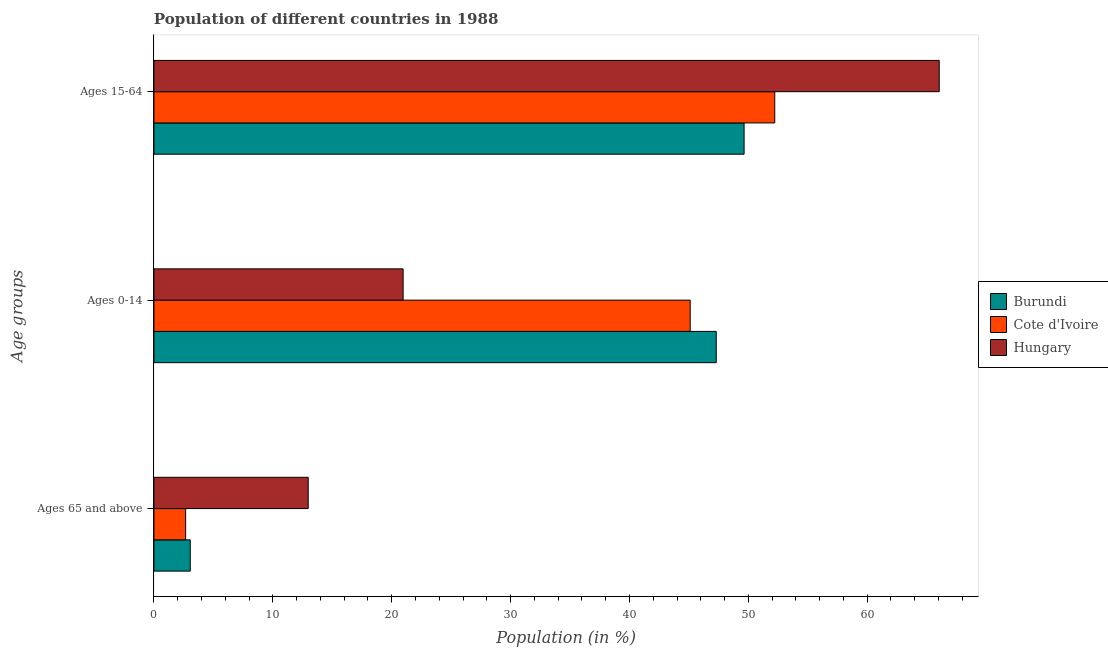How many groups of bars are there?
Your answer should be compact. 3. Are the number of bars per tick equal to the number of legend labels?
Give a very brief answer. Yes. How many bars are there on the 2nd tick from the top?
Provide a succinct answer. 3. What is the label of the 1st group of bars from the top?
Ensure brevity in your answer.  Ages 15-64. What is the percentage of population within the age-group of 65 and above in Burundi?
Ensure brevity in your answer.  3.06. Across all countries, what is the maximum percentage of population within the age-group of 65 and above?
Make the answer very short. 12.98. Across all countries, what is the minimum percentage of population within the age-group of 65 and above?
Ensure brevity in your answer.  2.67. In which country was the percentage of population within the age-group 15-64 maximum?
Offer a very short reply. Hungary. In which country was the percentage of population within the age-group 0-14 minimum?
Provide a succinct answer. Hungary. What is the total percentage of population within the age-group 15-64 in the graph?
Provide a succinct answer. 167.93. What is the difference between the percentage of population within the age-group of 65 and above in Cote d'Ivoire and that in Hungary?
Your answer should be compact. -10.31. What is the difference between the percentage of population within the age-group of 65 and above in Hungary and the percentage of population within the age-group 15-64 in Burundi?
Ensure brevity in your answer.  -36.67. What is the average percentage of population within the age-group 15-64 per country?
Offer a terse response. 55.98. What is the difference between the percentage of population within the age-group 0-14 and percentage of population within the age-group of 65 and above in Cote d'Ivoire?
Provide a short and direct response. 42.44. In how many countries, is the percentage of population within the age-group 0-14 greater than 52 %?
Your answer should be very brief. 0. What is the ratio of the percentage of population within the age-group 0-14 in Cote d'Ivoire to that in Burundi?
Your answer should be very brief. 0.95. Is the difference between the percentage of population within the age-group of 65 and above in Burundi and Hungary greater than the difference between the percentage of population within the age-group 0-14 in Burundi and Hungary?
Your response must be concise. No. What is the difference between the highest and the second highest percentage of population within the age-group 15-64?
Give a very brief answer. 13.84. What is the difference between the highest and the lowest percentage of population within the age-group 15-64?
Offer a very short reply. 16.42. Is the sum of the percentage of population within the age-group 15-64 in Hungary and Cote d'Ivoire greater than the maximum percentage of population within the age-group 0-14 across all countries?
Your answer should be compact. Yes. What does the 3rd bar from the top in Ages 15-64 represents?
Your answer should be very brief. Burundi. What does the 3rd bar from the bottom in Ages 0-14 represents?
Give a very brief answer. Hungary. What is the difference between two consecutive major ticks on the X-axis?
Keep it short and to the point. 10. Are the values on the major ticks of X-axis written in scientific E-notation?
Offer a terse response. No. How many legend labels are there?
Offer a terse response. 3. What is the title of the graph?
Make the answer very short. Population of different countries in 1988. Does "French Polynesia" appear as one of the legend labels in the graph?
Provide a short and direct response. No. What is the label or title of the X-axis?
Provide a succinct answer. Population (in %). What is the label or title of the Y-axis?
Ensure brevity in your answer.  Age groups. What is the Population (in %) in Burundi in Ages 65 and above?
Offer a terse response. 3.06. What is the Population (in %) in Cote d'Ivoire in Ages 65 and above?
Provide a short and direct response. 2.67. What is the Population (in %) of Hungary in Ages 65 and above?
Provide a short and direct response. 12.98. What is the Population (in %) of Burundi in Ages 0-14?
Provide a succinct answer. 47.3. What is the Population (in %) in Cote d'Ivoire in Ages 0-14?
Keep it short and to the point. 45.11. What is the Population (in %) in Hungary in Ages 0-14?
Your response must be concise. 20.96. What is the Population (in %) in Burundi in Ages 15-64?
Give a very brief answer. 49.64. What is the Population (in %) of Cote d'Ivoire in Ages 15-64?
Make the answer very short. 52.22. What is the Population (in %) of Hungary in Ages 15-64?
Your answer should be compact. 66.06. Across all Age groups, what is the maximum Population (in %) in Burundi?
Keep it short and to the point. 49.64. Across all Age groups, what is the maximum Population (in %) in Cote d'Ivoire?
Provide a succinct answer. 52.22. Across all Age groups, what is the maximum Population (in %) of Hungary?
Your answer should be compact. 66.06. Across all Age groups, what is the minimum Population (in %) of Burundi?
Offer a very short reply. 3.06. Across all Age groups, what is the minimum Population (in %) of Cote d'Ivoire?
Give a very brief answer. 2.67. Across all Age groups, what is the minimum Population (in %) in Hungary?
Your answer should be compact. 12.98. What is the total Population (in %) in Burundi in the graph?
Your response must be concise. 100. What is the difference between the Population (in %) in Burundi in Ages 65 and above and that in Ages 0-14?
Provide a short and direct response. -44.25. What is the difference between the Population (in %) of Cote d'Ivoire in Ages 65 and above and that in Ages 0-14?
Ensure brevity in your answer.  -42.44. What is the difference between the Population (in %) in Hungary in Ages 65 and above and that in Ages 0-14?
Keep it short and to the point. -7.98. What is the difference between the Population (in %) of Burundi in Ages 65 and above and that in Ages 15-64?
Your response must be concise. -46.59. What is the difference between the Population (in %) of Cote d'Ivoire in Ages 65 and above and that in Ages 15-64?
Make the answer very short. -49.56. What is the difference between the Population (in %) of Hungary in Ages 65 and above and that in Ages 15-64?
Provide a short and direct response. -53.08. What is the difference between the Population (in %) of Burundi in Ages 0-14 and that in Ages 15-64?
Keep it short and to the point. -2.34. What is the difference between the Population (in %) in Cote d'Ivoire in Ages 0-14 and that in Ages 15-64?
Keep it short and to the point. -7.11. What is the difference between the Population (in %) of Hungary in Ages 0-14 and that in Ages 15-64?
Ensure brevity in your answer.  -45.1. What is the difference between the Population (in %) in Burundi in Ages 65 and above and the Population (in %) in Cote d'Ivoire in Ages 0-14?
Offer a very short reply. -42.06. What is the difference between the Population (in %) of Burundi in Ages 65 and above and the Population (in %) of Hungary in Ages 0-14?
Make the answer very short. -17.91. What is the difference between the Population (in %) in Cote d'Ivoire in Ages 65 and above and the Population (in %) in Hungary in Ages 0-14?
Make the answer very short. -18.3. What is the difference between the Population (in %) in Burundi in Ages 65 and above and the Population (in %) in Cote d'Ivoire in Ages 15-64?
Provide a short and direct response. -49.17. What is the difference between the Population (in %) of Burundi in Ages 65 and above and the Population (in %) of Hungary in Ages 15-64?
Offer a very short reply. -63. What is the difference between the Population (in %) in Cote d'Ivoire in Ages 65 and above and the Population (in %) in Hungary in Ages 15-64?
Make the answer very short. -63.39. What is the difference between the Population (in %) in Burundi in Ages 0-14 and the Population (in %) in Cote d'Ivoire in Ages 15-64?
Make the answer very short. -4.92. What is the difference between the Population (in %) in Burundi in Ages 0-14 and the Population (in %) in Hungary in Ages 15-64?
Offer a terse response. -18.76. What is the difference between the Population (in %) of Cote d'Ivoire in Ages 0-14 and the Population (in %) of Hungary in Ages 15-64?
Provide a short and direct response. -20.95. What is the average Population (in %) of Burundi per Age groups?
Your response must be concise. 33.33. What is the average Population (in %) in Cote d'Ivoire per Age groups?
Your answer should be compact. 33.33. What is the average Population (in %) in Hungary per Age groups?
Your response must be concise. 33.33. What is the difference between the Population (in %) of Burundi and Population (in %) of Cote d'Ivoire in Ages 65 and above?
Make the answer very short. 0.39. What is the difference between the Population (in %) in Burundi and Population (in %) in Hungary in Ages 65 and above?
Your answer should be very brief. -9.92. What is the difference between the Population (in %) in Cote d'Ivoire and Population (in %) in Hungary in Ages 65 and above?
Make the answer very short. -10.31. What is the difference between the Population (in %) of Burundi and Population (in %) of Cote d'Ivoire in Ages 0-14?
Keep it short and to the point. 2.19. What is the difference between the Population (in %) of Burundi and Population (in %) of Hungary in Ages 0-14?
Your answer should be compact. 26.34. What is the difference between the Population (in %) of Cote d'Ivoire and Population (in %) of Hungary in Ages 0-14?
Your answer should be compact. 24.15. What is the difference between the Population (in %) in Burundi and Population (in %) in Cote d'Ivoire in Ages 15-64?
Keep it short and to the point. -2.58. What is the difference between the Population (in %) in Burundi and Population (in %) in Hungary in Ages 15-64?
Provide a short and direct response. -16.42. What is the difference between the Population (in %) of Cote d'Ivoire and Population (in %) of Hungary in Ages 15-64?
Your answer should be compact. -13.84. What is the ratio of the Population (in %) in Burundi in Ages 65 and above to that in Ages 0-14?
Ensure brevity in your answer.  0.06. What is the ratio of the Population (in %) in Cote d'Ivoire in Ages 65 and above to that in Ages 0-14?
Provide a short and direct response. 0.06. What is the ratio of the Population (in %) of Hungary in Ages 65 and above to that in Ages 0-14?
Ensure brevity in your answer.  0.62. What is the ratio of the Population (in %) of Burundi in Ages 65 and above to that in Ages 15-64?
Offer a terse response. 0.06. What is the ratio of the Population (in %) in Cote d'Ivoire in Ages 65 and above to that in Ages 15-64?
Your response must be concise. 0.05. What is the ratio of the Population (in %) of Hungary in Ages 65 and above to that in Ages 15-64?
Offer a very short reply. 0.2. What is the ratio of the Population (in %) in Burundi in Ages 0-14 to that in Ages 15-64?
Give a very brief answer. 0.95. What is the ratio of the Population (in %) in Cote d'Ivoire in Ages 0-14 to that in Ages 15-64?
Offer a terse response. 0.86. What is the ratio of the Population (in %) in Hungary in Ages 0-14 to that in Ages 15-64?
Your answer should be compact. 0.32. What is the difference between the highest and the second highest Population (in %) in Burundi?
Provide a short and direct response. 2.34. What is the difference between the highest and the second highest Population (in %) in Cote d'Ivoire?
Keep it short and to the point. 7.11. What is the difference between the highest and the second highest Population (in %) in Hungary?
Provide a succinct answer. 45.1. What is the difference between the highest and the lowest Population (in %) of Burundi?
Offer a very short reply. 46.59. What is the difference between the highest and the lowest Population (in %) of Cote d'Ivoire?
Offer a terse response. 49.56. What is the difference between the highest and the lowest Population (in %) in Hungary?
Provide a short and direct response. 53.08. 